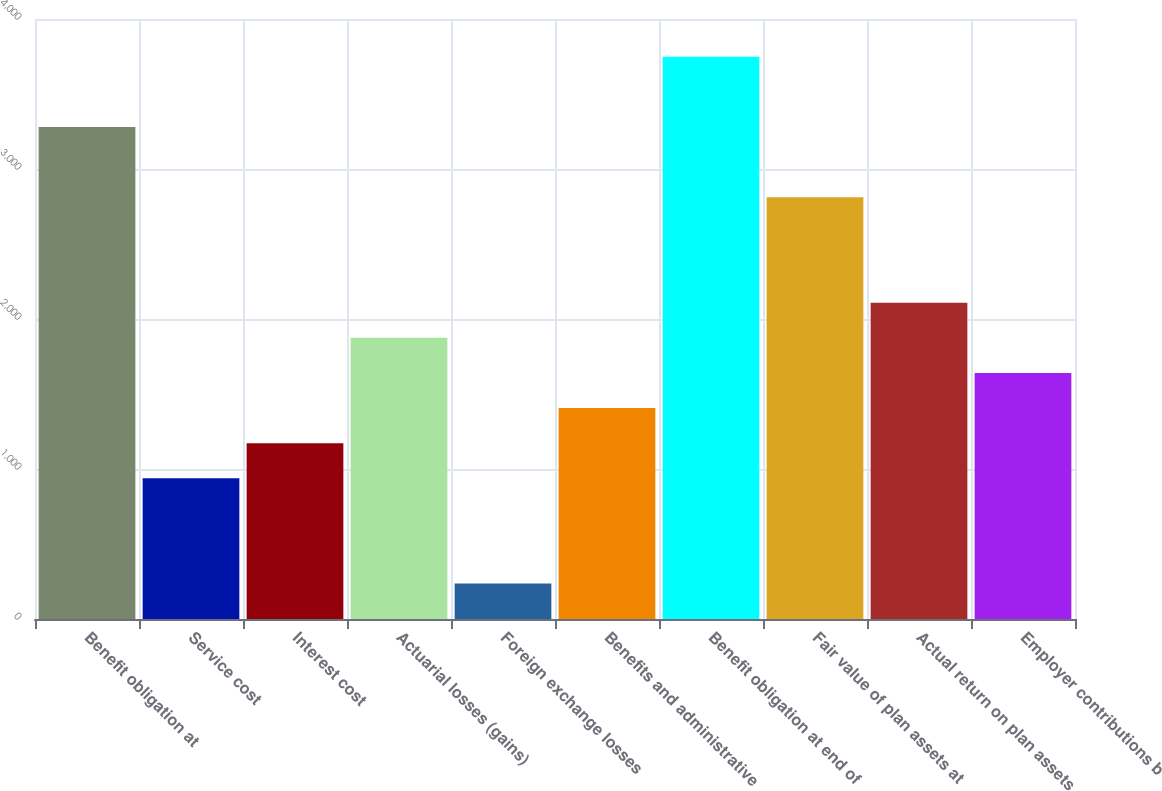<chart> <loc_0><loc_0><loc_500><loc_500><bar_chart><fcel>Benefit obligation at<fcel>Service cost<fcel>Interest cost<fcel>Actuarial losses (gains)<fcel>Foreign exchange losses<fcel>Benefits and administrative<fcel>Benefit obligation at end of<fcel>Fair value of plan assets at<fcel>Actual return on plan assets<fcel>Employer contributions b<nl><fcel>3279.4<fcel>938.4<fcel>1172.5<fcel>1874.8<fcel>236.1<fcel>1406.6<fcel>3747.6<fcel>2811.2<fcel>2108.9<fcel>1640.7<nl></chart> 